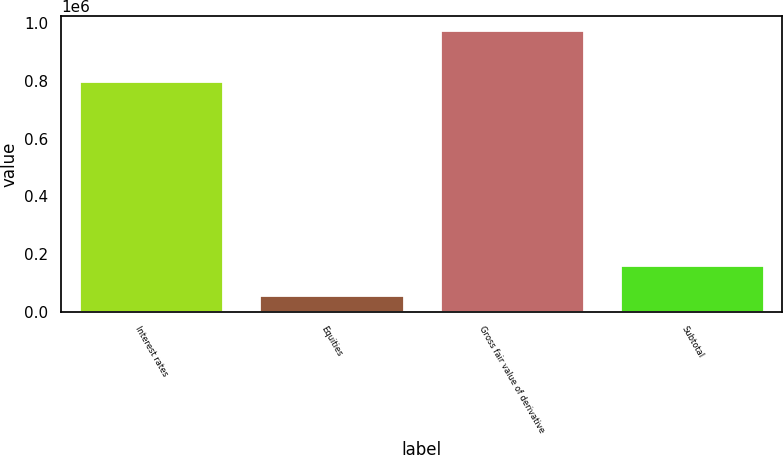Convert chart. <chart><loc_0><loc_0><loc_500><loc_500><bar_chart><fcel>Interest rates<fcel>Equities<fcel>Gross fair value of derivative<fcel>Subtotal<nl><fcel>800028<fcel>58122<fcel>976648<fcel>160514<nl></chart> 